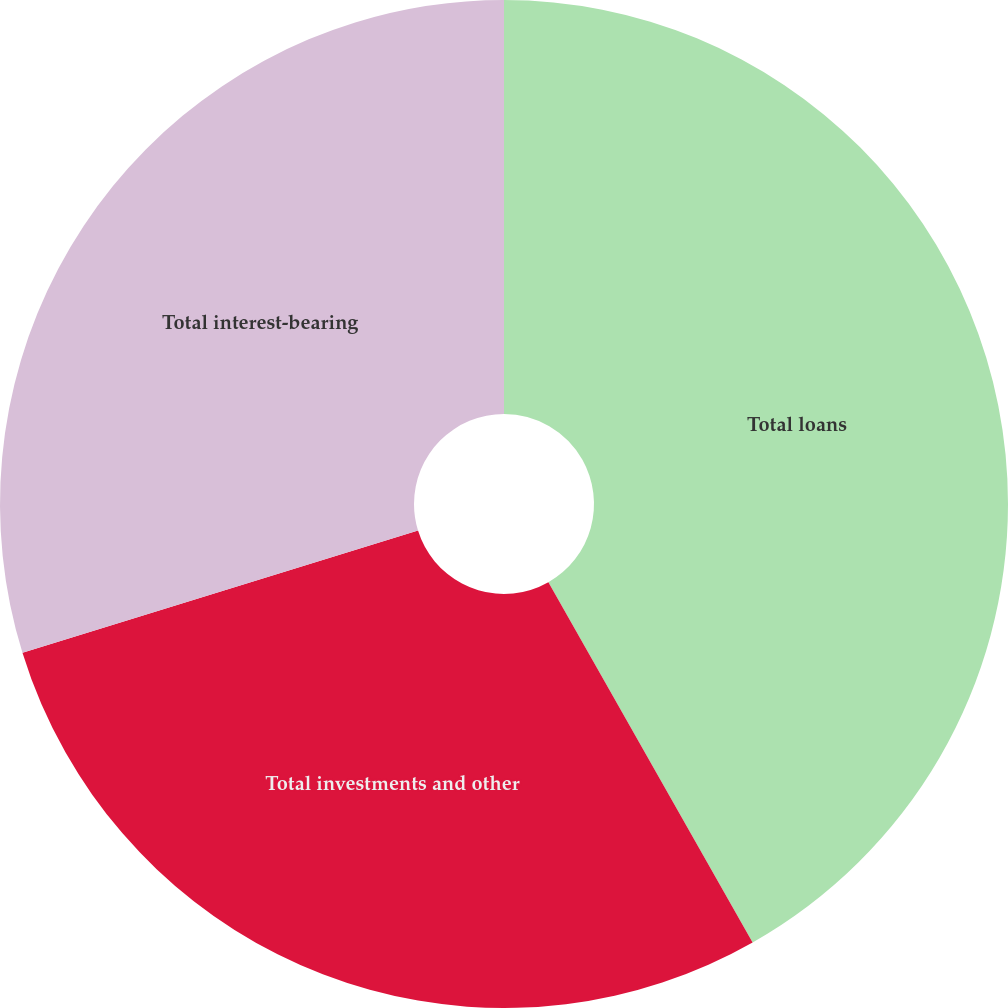Convert chart to OTSL. <chart><loc_0><loc_0><loc_500><loc_500><pie_chart><fcel>Total loans<fcel>Total investments and other<fcel>Total interest-bearing<nl><fcel>41.79%<fcel>28.44%<fcel>29.77%<nl></chart> 